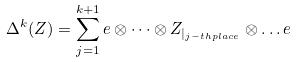<formula> <loc_0><loc_0><loc_500><loc_500>\Delta ^ { k } ( Z ) = \sum _ { j = 1 } ^ { k + 1 } e \otimes \dots \otimes Z _ { | _ { j - t h p l a c e } } \otimes \dots e</formula> 